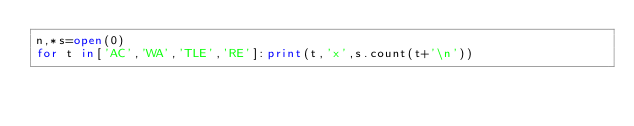Convert code to text. <code><loc_0><loc_0><loc_500><loc_500><_Python_>n,*s=open(0)
for t in['AC','WA','TLE','RE']:print(t,'x',s.count(t+'\n'))</code> 